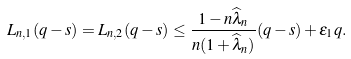<formula> <loc_0><loc_0><loc_500><loc_500>L _ { n , 1 } ( q - s ) = L _ { n , 2 } ( q - s ) \leq \frac { 1 - n \widehat { \lambda } _ { n } } { n ( 1 + \widehat { \lambda } _ { n } ) } ( q - s ) + \epsilon _ { 1 } q .</formula> 